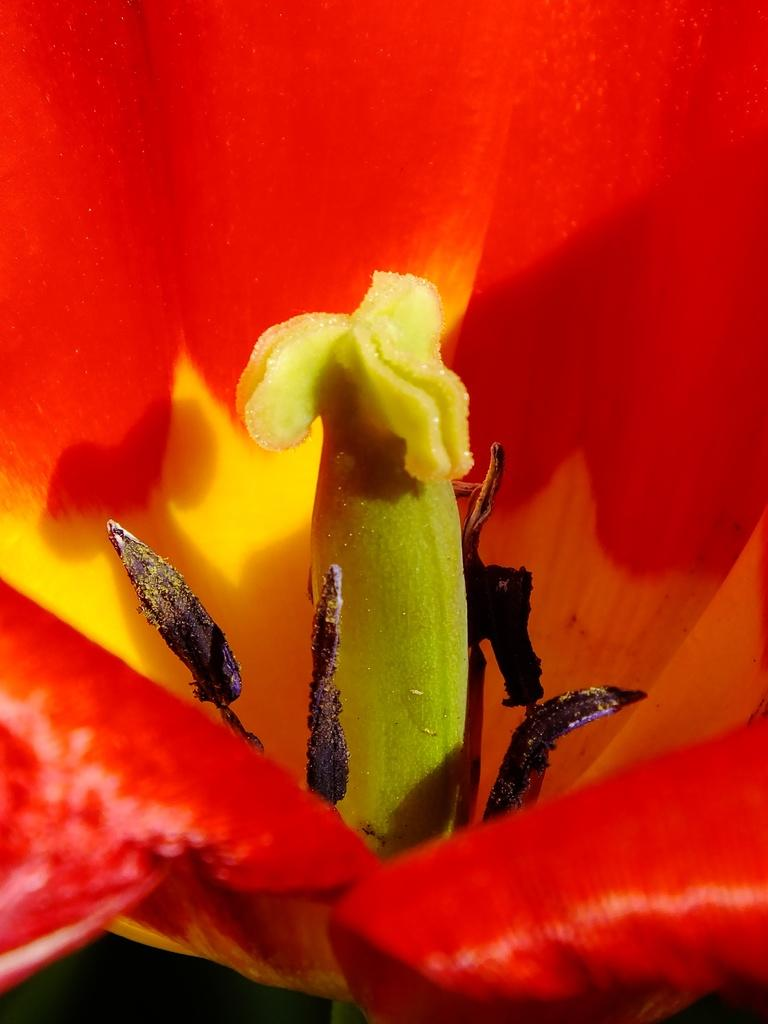What type of flower is in the image? There is a red flower in the image. What can be found in the center of the red flower? The red flower has stamens. Are there any icicles hanging from the red flower in the image? No, there are no icicles present in the image. 